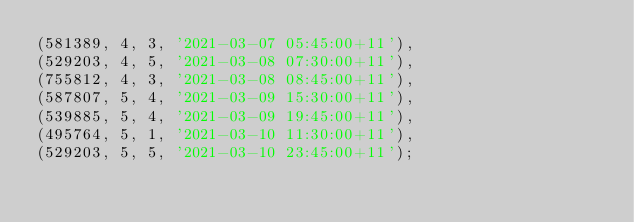Convert code to text. <code><loc_0><loc_0><loc_500><loc_500><_SQL_>(581389, 4, 3, '2021-03-07 05:45:00+11'),
(529203, 4, 5, '2021-03-08 07:30:00+11'),
(755812, 4, 3, '2021-03-08 08:45:00+11'),
(587807, 5, 4, '2021-03-09 15:30:00+11'),
(539885, 5, 4, '2021-03-09 19:45:00+11'),
(495764, 5, 1, '2021-03-10 11:30:00+11'),
(529203, 5, 5, '2021-03-10 23:45:00+11');</code> 